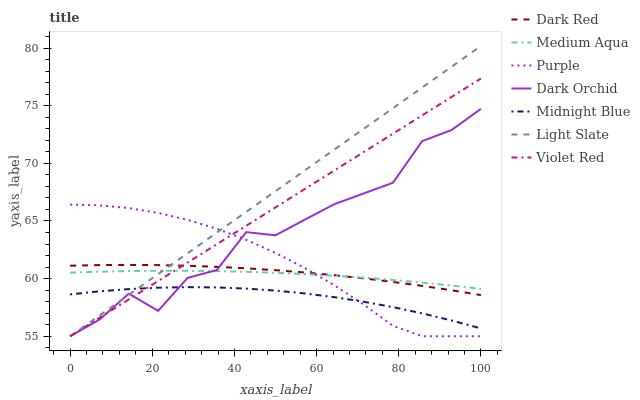Does Midnight Blue have the minimum area under the curve?
Answer yes or no. Yes. Does Light Slate have the maximum area under the curve?
Answer yes or no. Yes. Does Purple have the minimum area under the curve?
Answer yes or no. No. Does Purple have the maximum area under the curve?
Answer yes or no. No. Is Violet Red the smoothest?
Answer yes or no. Yes. Is Dark Orchid the roughest?
Answer yes or no. Yes. Is Midnight Blue the smoothest?
Answer yes or no. No. Is Midnight Blue the roughest?
Answer yes or no. No. Does Violet Red have the lowest value?
Answer yes or no. Yes. Does Midnight Blue have the lowest value?
Answer yes or no. No. Does Light Slate have the highest value?
Answer yes or no. Yes. Does Purple have the highest value?
Answer yes or no. No. Is Midnight Blue less than Medium Aqua?
Answer yes or no. Yes. Is Medium Aqua greater than Midnight Blue?
Answer yes or no. Yes. Does Violet Red intersect Medium Aqua?
Answer yes or no. Yes. Is Violet Red less than Medium Aqua?
Answer yes or no. No. Is Violet Red greater than Medium Aqua?
Answer yes or no. No. Does Midnight Blue intersect Medium Aqua?
Answer yes or no. No. 